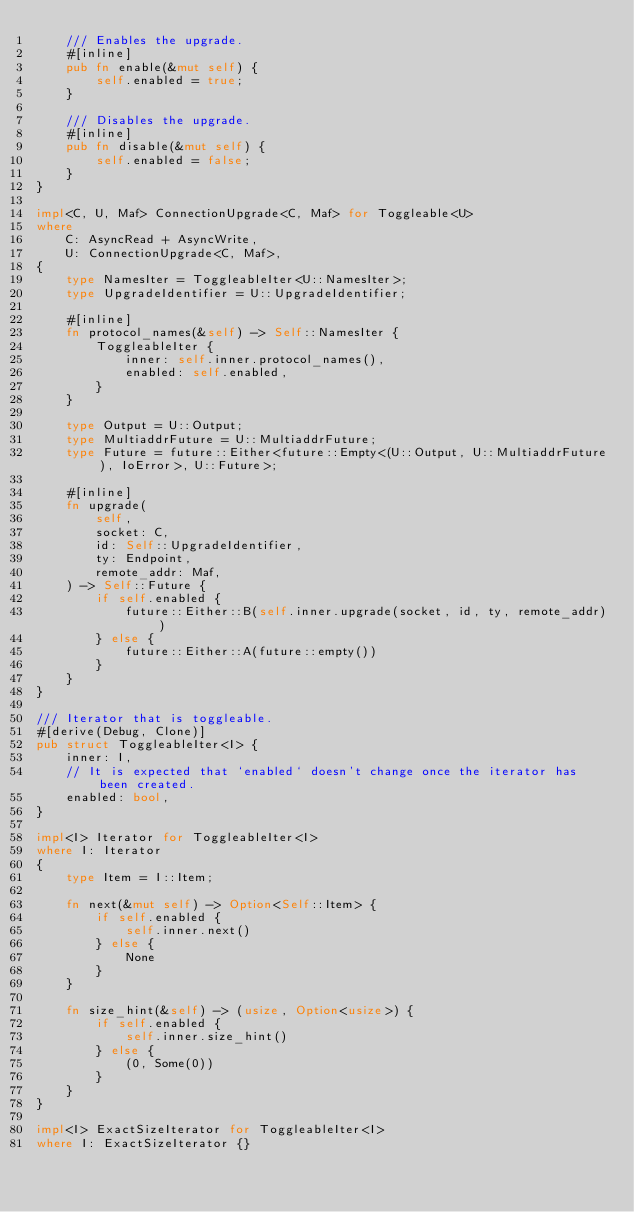<code> <loc_0><loc_0><loc_500><loc_500><_Rust_>    /// Enables the upgrade.
    #[inline]
    pub fn enable(&mut self) {
        self.enabled = true;
    }

    /// Disables the upgrade.
    #[inline]
    pub fn disable(&mut self) {
        self.enabled = false;
    }
}

impl<C, U, Maf> ConnectionUpgrade<C, Maf> for Toggleable<U>
where
    C: AsyncRead + AsyncWrite,
    U: ConnectionUpgrade<C, Maf>,
{
    type NamesIter = ToggleableIter<U::NamesIter>;
    type UpgradeIdentifier = U::UpgradeIdentifier;

    #[inline]
    fn protocol_names(&self) -> Self::NamesIter {
        ToggleableIter {
            inner: self.inner.protocol_names(),
            enabled: self.enabled,
        }
    }

    type Output = U::Output;
    type MultiaddrFuture = U::MultiaddrFuture;
    type Future = future::Either<future::Empty<(U::Output, U::MultiaddrFuture), IoError>, U::Future>;

    #[inline]
    fn upgrade(
        self,
        socket: C,
        id: Self::UpgradeIdentifier,
        ty: Endpoint,
        remote_addr: Maf,
    ) -> Self::Future {
        if self.enabled {
            future::Either::B(self.inner.upgrade(socket, id, ty, remote_addr))
        } else {
            future::Either::A(future::empty())
        }
    }
}

/// Iterator that is toggleable.
#[derive(Debug, Clone)]
pub struct ToggleableIter<I> {
    inner: I,
    // It is expected that `enabled` doesn't change once the iterator has been created.
    enabled: bool,
}

impl<I> Iterator for ToggleableIter<I>
where I: Iterator
{
    type Item = I::Item;

    fn next(&mut self) -> Option<Self::Item> {
        if self.enabled {
            self.inner.next()
        } else {
            None
        }
    }

    fn size_hint(&self) -> (usize, Option<usize>) {
        if self.enabled {
            self.inner.size_hint()
        } else {
            (0, Some(0))
        }
    }
}

impl<I> ExactSizeIterator for ToggleableIter<I>
where I: ExactSizeIterator {}
</code> 